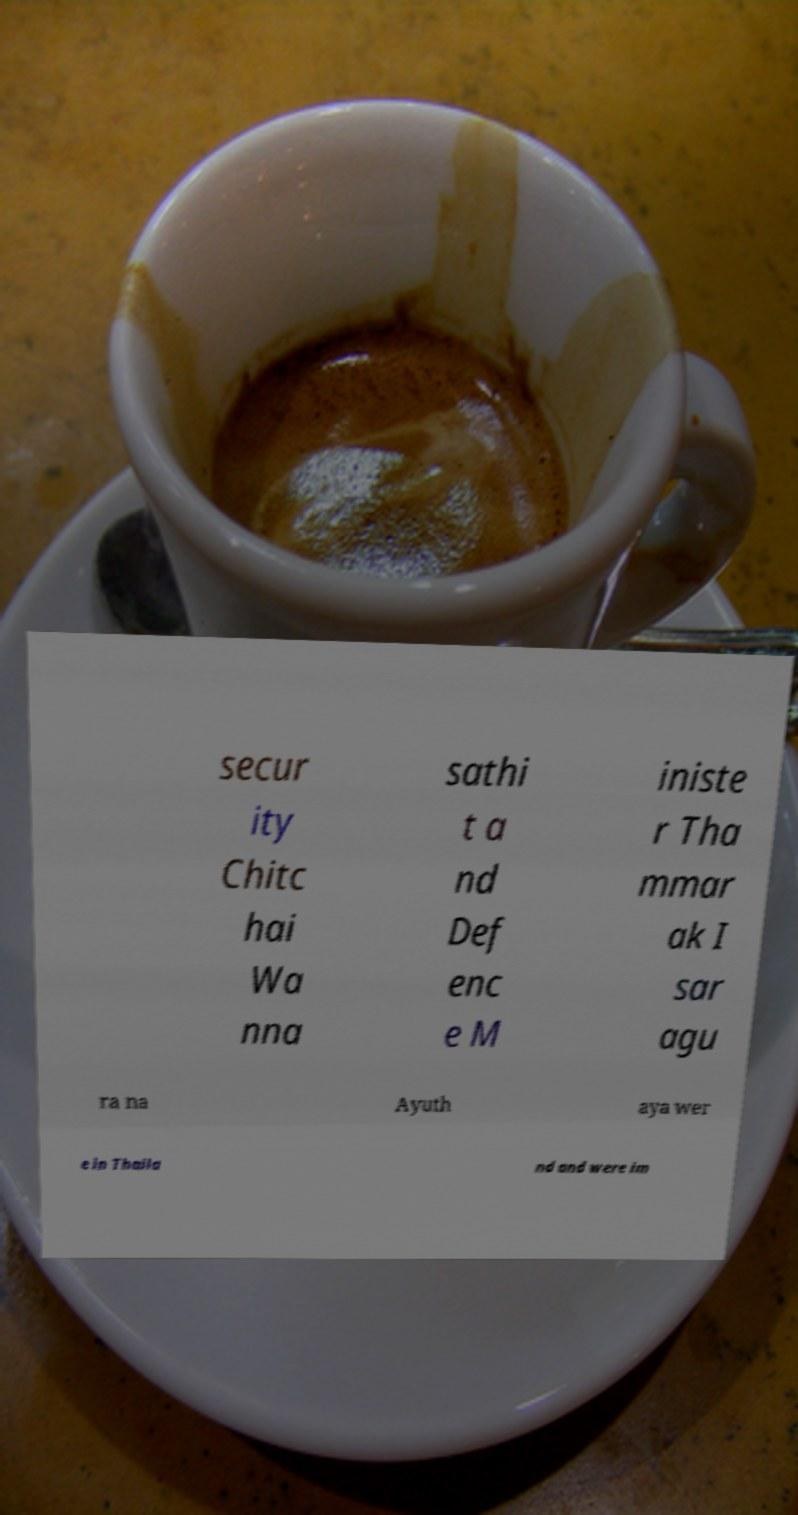Please read and relay the text visible in this image. What does it say? secur ity Chitc hai Wa nna sathi t a nd Def enc e M iniste r Tha mmar ak I sar agu ra na Ayuth aya wer e in Thaila nd and were im 